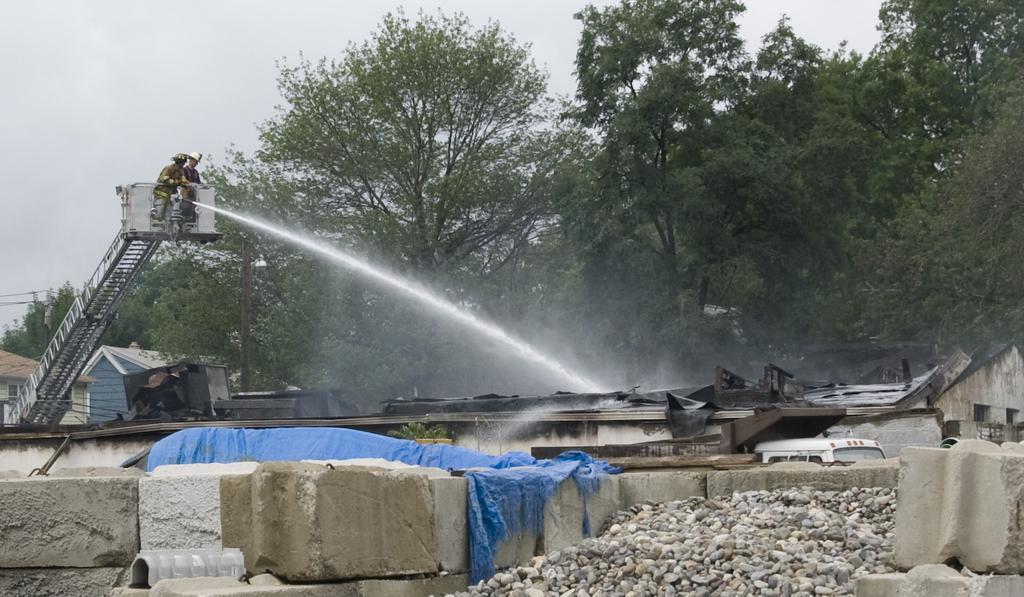In one or two sentences, can you explain what this image depicts? In this image there are bricks, there is a metal object, it looks like a cover, there is water, there are people, there are buildings, trees on the left corner. There are stones, there is a vehicle on the right corner. There are trees in the background. And there is sky at the top. 